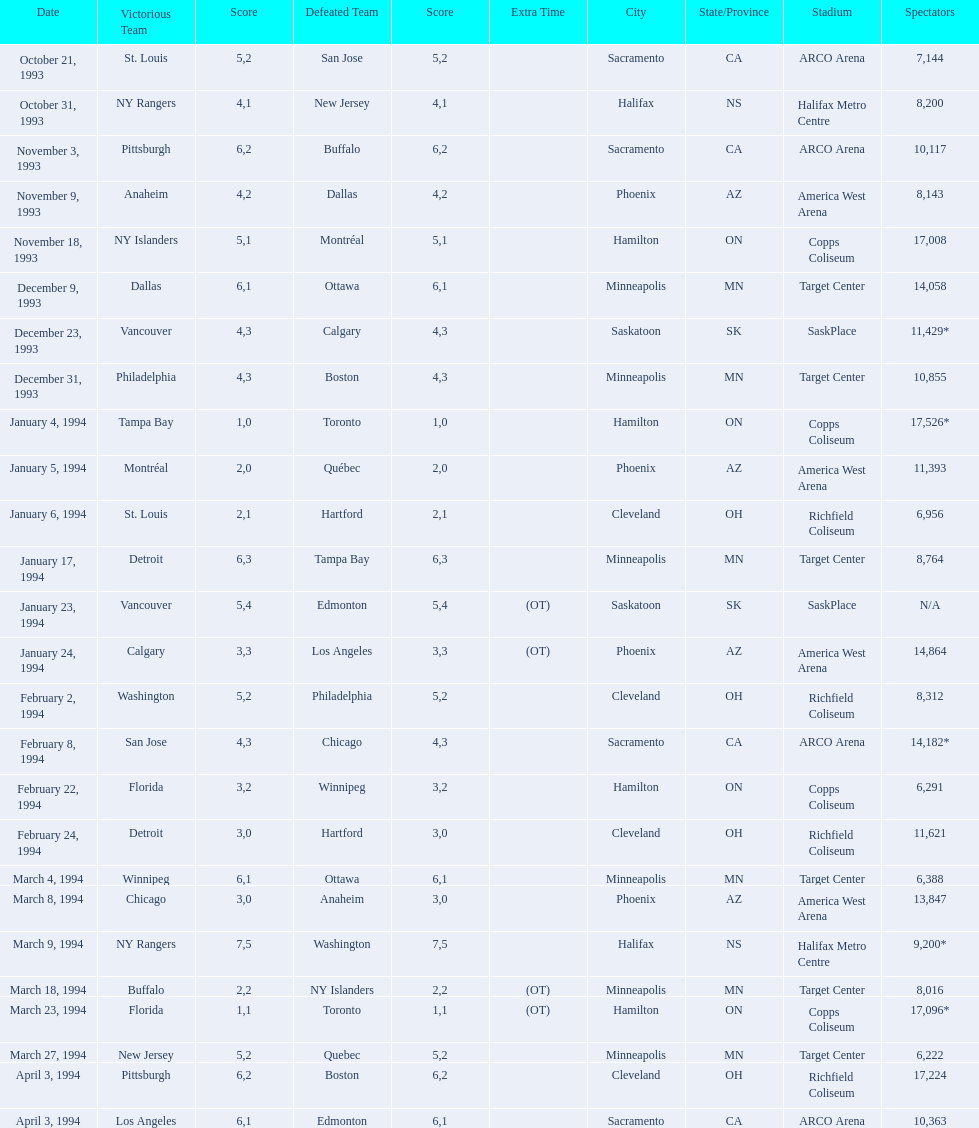Can you parse all the data within this table? {'header': ['Date', 'Victorious Team', 'Score', 'Defeated Team', 'Score', 'Extra Time', 'City', 'State/Province', 'Stadium', 'Spectators'], 'rows': [['October 21, 1993', 'St. Louis', '5', 'San Jose', '2', '', 'Sacramento', 'CA', 'ARCO Arena', '7,144'], ['October 31, 1993', 'NY Rangers', '4', 'New Jersey', '1', '', 'Halifax', 'NS', 'Halifax Metro Centre', '8,200'], ['November 3, 1993', 'Pittsburgh', '6', 'Buffalo', '2', '', 'Sacramento', 'CA', 'ARCO Arena', '10,117'], ['November 9, 1993', 'Anaheim', '4', 'Dallas', '2', '', 'Phoenix', 'AZ', 'America West Arena', '8,143'], ['November 18, 1993', 'NY Islanders', '5', 'Montréal', '1', '', 'Hamilton', 'ON', 'Copps Coliseum', '17,008'], ['December 9, 1993', 'Dallas', '6', 'Ottawa', '1', '', 'Minneapolis', 'MN', 'Target Center', '14,058'], ['December 23, 1993', 'Vancouver', '4', 'Calgary', '3', '', 'Saskatoon', 'SK', 'SaskPlace', '11,429*'], ['December 31, 1993', 'Philadelphia', '4', 'Boston', '3', '', 'Minneapolis', 'MN', 'Target Center', '10,855'], ['January 4, 1994', 'Tampa Bay', '1', 'Toronto', '0', '', 'Hamilton', 'ON', 'Copps Coliseum', '17,526*'], ['January 5, 1994', 'Montréal', '2', 'Québec', '0', '', 'Phoenix', 'AZ', 'America West Arena', '11,393'], ['January 6, 1994', 'St. Louis', '2', 'Hartford', '1', '', 'Cleveland', 'OH', 'Richfield Coliseum', '6,956'], ['January 17, 1994', 'Detroit', '6', 'Tampa Bay', '3', '', 'Minneapolis', 'MN', 'Target Center', '8,764'], ['January 23, 1994', 'Vancouver', '5', 'Edmonton', '4', '(OT)', 'Saskatoon', 'SK', 'SaskPlace', 'N/A'], ['January 24, 1994', 'Calgary', '3', 'Los Angeles', '3', '(OT)', 'Phoenix', 'AZ', 'America West Arena', '14,864'], ['February 2, 1994', 'Washington', '5', 'Philadelphia', '2', '', 'Cleveland', 'OH', 'Richfield Coliseum', '8,312'], ['February 8, 1994', 'San Jose', '4', 'Chicago', '3', '', 'Sacramento', 'CA', 'ARCO Arena', '14,182*'], ['February 22, 1994', 'Florida', '3', 'Winnipeg', '2', '', 'Hamilton', 'ON', 'Copps Coliseum', '6,291'], ['February 24, 1994', 'Detroit', '3', 'Hartford', '0', '', 'Cleveland', 'OH', 'Richfield Coliseum', '11,621'], ['March 4, 1994', 'Winnipeg', '6', 'Ottawa', '1', '', 'Minneapolis', 'MN', 'Target Center', '6,388'], ['March 8, 1994', 'Chicago', '3', 'Anaheim', '0', '', 'Phoenix', 'AZ', 'America West Arena', '13,847'], ['March 9, 1994', 'NY Rangers', '7', 'Washington', '5', '', 'Halifax', 'NS', 'Halifax Metro Centre', '9,200*'], ['March 18, 1994', 'Buffalo', '2', 'NY Islanders', '2', '(OT)', 'Minneapolis', 'MN', 'Target Center', '8,016'], ['March 23, 1994', 'Florida', '1', 'Toronto', '1', '(OT)', 'Hamilton', 'ON', 'Copps Coliseum', '17,096*'], ['March 27, 1994', 'New Jersey', '5', 'Quebec', '2', '', 'Minneapolis', 'MN', 'Target Center', '6,222'], ['April 3, 1994', 'Pittsburgh', '6', 'Boston', '2', '', 'Cleveland', 'OH', 'Richfield Coliseum', '17,224'], ['April 3, 1994', 'Los Angeles', '6', 'Edmonton', '1', '', 'Sacramento', 'CA', 'ARCO Arena', '10,363']]} How many more people attended the november 18, 1993 games than the november 9th game? 8865. 